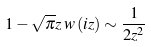Convert formula to latex. <formula><loc_0><loc_0><loc_500><loc_500>1 - \sqrt { \pi } z \, w \left ( i z \right ) \sim \frac { 1 } { 2 z ^ { 2 } }</formula> 